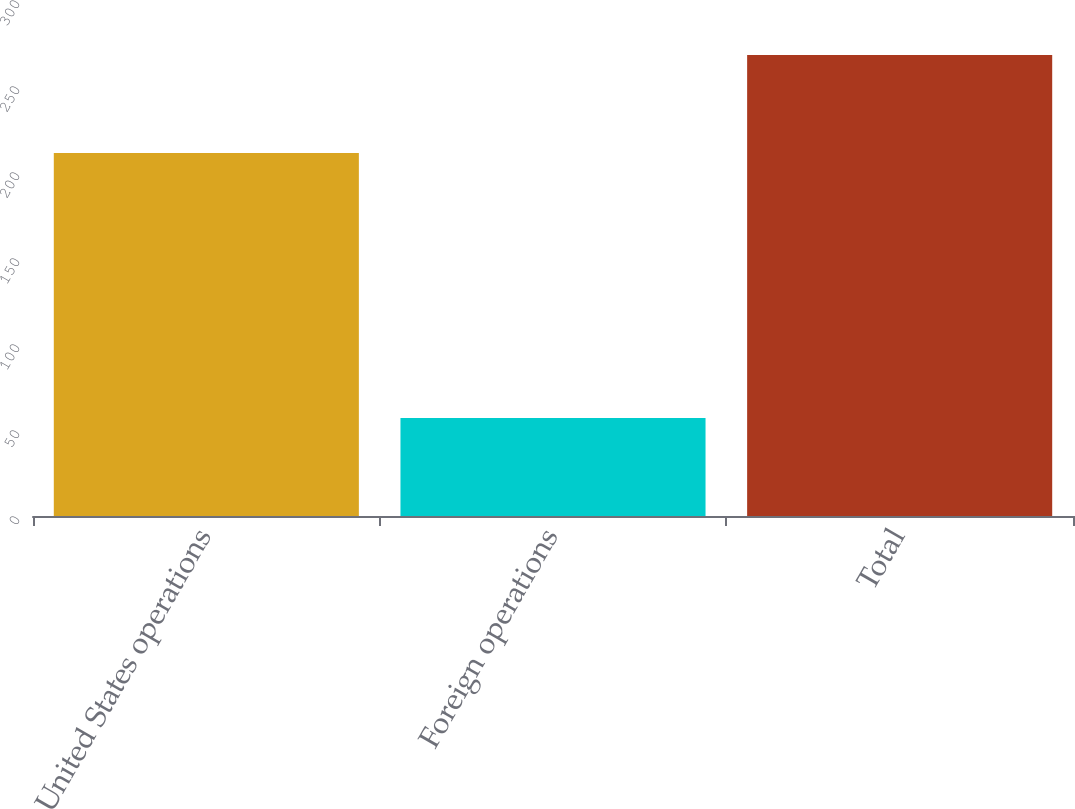<chart> <loc_0><loc_0><loc_500><loc_500><bar_chart><fcel>United States operations<fcel>Foreign operations<fcel>Total<nl><fcel>211<fcel>57<fcel>268<nl></chart> 